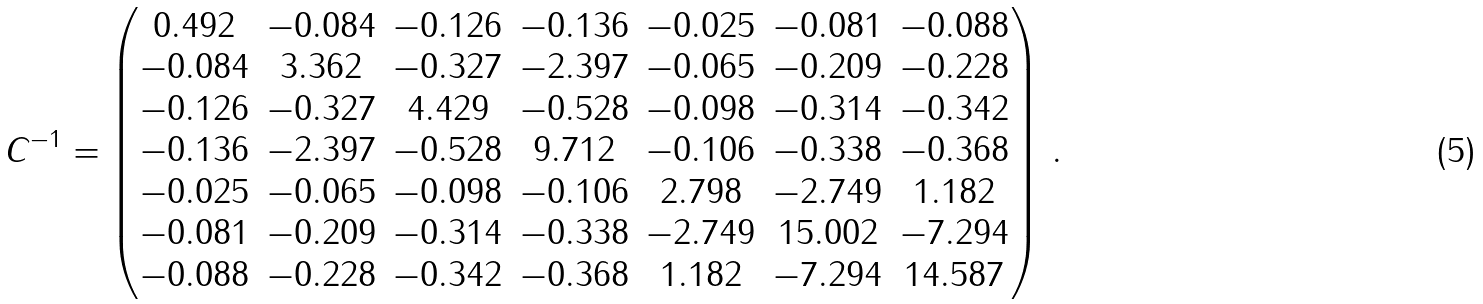Convert formula to latex. <formula><loc_0><loc_0><loc_500><loc_500>C ^ { - 1 } = \begin{pmatrix} 0 . 4 9 2 & - 0 . 0 8 4 & - 0 . 1 2 6 & - 0 . 1 3 6 & - 0 . 0 2 5 & - 0 . 0 8 1 & - 0 . 0 8 8 \\ - 0 . 0 8 4 & 3 . 3 6 2 & - 0 . 3 2 7 & - 2 . 3 9 7 & - 0 . 0 6 5 & - 0 . 2 0 9 & - 0 . 2 2 8 \\ - 0 . 1 2 6 & - 0 . 3 2 7 & 4 . 4 2 9 & - 0 . 5 2 8 & - 0 . 0 9 8 & - 0 . 3 1 4 & - 0 . 3 4 2 \\ - 0 . 1 3 6 & - 2 . 3 9 7 & - 0 . 5 2 8 & 9 . 7 1 2 & - 0 . 1 0 6 & - 0 . 3 3 8 & - 0 . 3 6 8 \\ - 0 . 0 2 5 & - 0 . 0 6 5 & - 0 . 0 9 8 & - 0 . 1 0 6 & 2 . 7 9 8 & - 2 . 7 4 9 & 1 . 1 8 2 \\ - 0 . 0 8 1 & - 0 . 2 0 9 & - 0 . 3 1 4 & - 0 . 3 3 8 & - 2 . 7 4 9 & 1 5 . 0 0 2 & - 7 . 2 9 4 \\ - 0 . 0 8 8 & - 0 . 2 2 8 & - 0 . 3 4 2 & - 0 . 3 6 8 & 1 . 1 8 2 & - 7 . 2 9 4 & 1 4 . 5 8 7 \\ \end{pmatrix} \, .</formula> 